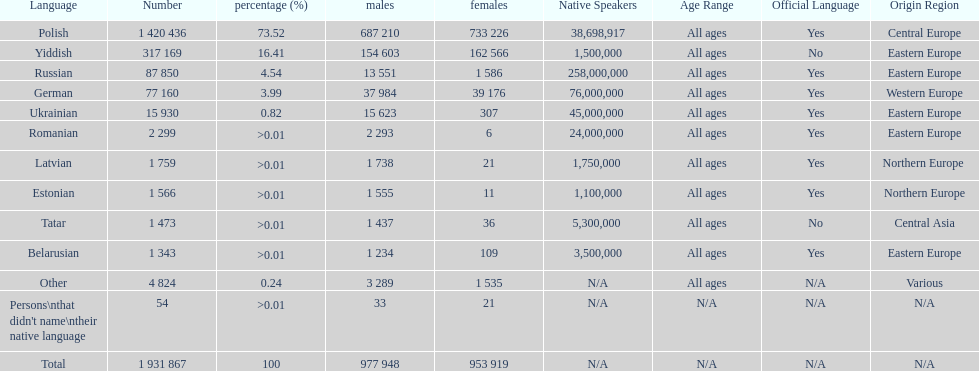What are the languages of the warsaw governorate? Polish, Yiddish, Russian, German, Ukrainian, Romanian, Latvian, Estonian, Tatar, Belarusian, Other. What is the percentage of polish? 73.52. What is the next highest amount? 16.41. What is the language with this amount? Yiddish. 